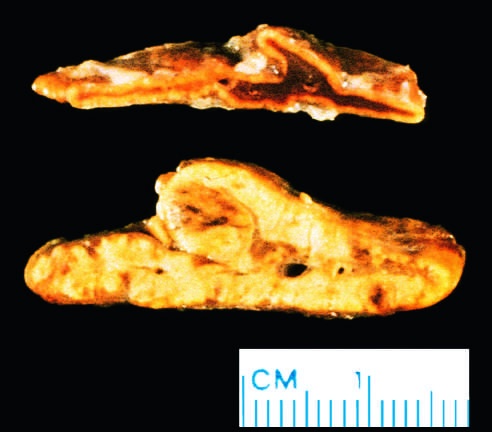was the abnormal gland from a patient with acth-dependent cushing syndrome, in whom both adrenal glands were diffusely hyperplastic?
Answer the question using a single word or phrase. Yes 